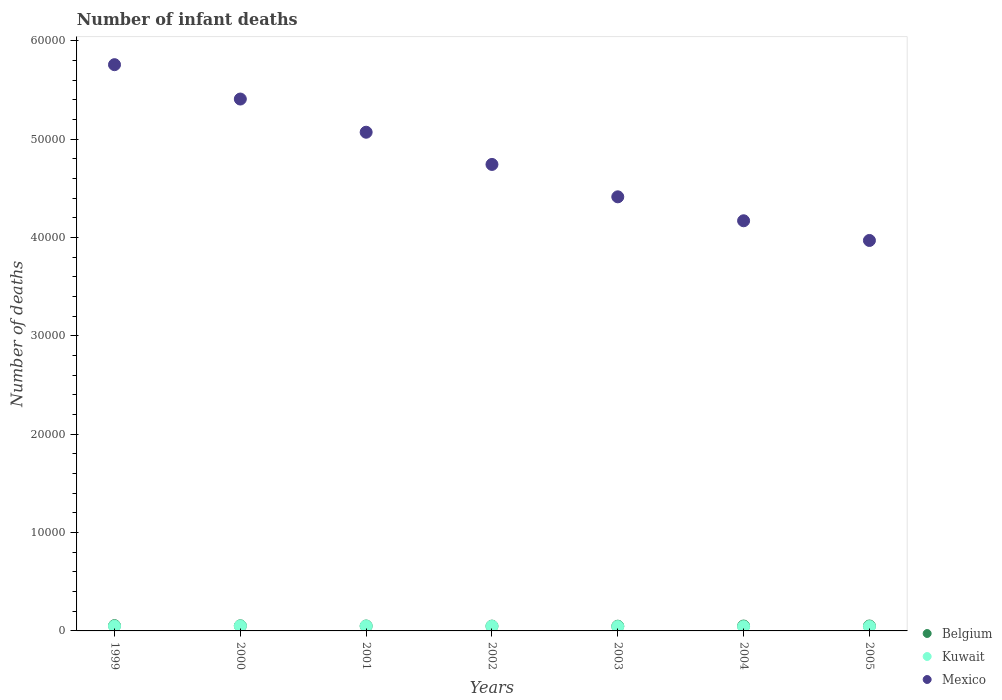How many different coloured dotlines are there?
Ensure brevity in your answer.  3. Is the number of dotlines equal to the number of legend labels?
Ensure brevity in your answer.  Yes. What is the number of infant deaths in Belgium in 2004?
Provide a short and direct response. 497. Across all years, what is the maximum number of infant deaths in Belgium?
Give a very brief answer. 536. Across all years, what is the minimum number of infant deaths in Belgium?
Make the answer very short. 481. In which year was the number of infant deaths in Kuwait maximum?
Offer a terse response. 2000. What is the total number of infant deaths in Mexico in the graph?
Your answer should be compact. 3.35e+05. What is the difference between the number of infant deaths in Mexico in 2000 and that in 2005?
Your answer should be very brief. 1.44e+04. What is the difference between the number of infant deaths in Kuwait in 2002 and the number of infant deaths in Mexico in 1999?
Give a very brief answer. -5.71e+04. What is the average number of infant deaths in Kuwait per year?
Offer a very short reply. 466.86. In the year 2005, what is the difference between the number of infant deaths in Mexico and number of infant deaths in Belgium?
Make the answer very short. 3.92e+04. In how many years, is the number of infant deaths in Belgium greater than 6000?
Provide a succinct answer. 0. What is the ratio of the number of infant deaths in Kuwait in 2000 to that in 2002?
Provide a short and direct response. 1.07. What is the difference between the highest and the second highest number of infant deaths in Belgium?
Your answer should be very brief. 16. What is the difference between the highest and the lowest number of infant deaths in Mexico?
Keep it short and to the point. 1.79e+04. Is the sum of the number of infant deaths in Kuwait in 1999 and 2000 greater than the maximum number of infant deaths in Mexico across all years?
Your answer should be compact. No. Does the number of infant deaths in Mexico monotonically increase over the years?
Provide a short and direct response. No. How many dotlines are there?
Keep it short and to the point. 3. Are the values on the major ticks of Y-axis written in scientific E-notation?
Your answer should be very brief. No. Does the graph contain any zero values?
Provide a short and direct response. No. Where does the legend appear in the graph?
Give a very brief answer. Bottom right. How many legend labels are there?
Provide a short and direct response. 3. What is the title of the graph?
Your answer should be compact. Number of infant deaths. Does "San Marino" appear as one of the legend labels in the graph?
Ensure brevity in your answer.  No. What is the label or title of the Y-axis?
Make the answer very short. Number of deaths. What is the Number of deaths of Belgium in 1999?
Provide a short and direct response. 536. What is the Number of deaths of Kuwait in 1999?
Give a very brief answer. 485. What is the Number of deaths of Mexico in 1999?
Your answer should be very brief. 5.76e+04. What is the Number of deaths of Belgium in 2000?
Your answer should be very brief. 520. What is the Number of deaths in Kuwait in 2000?
Give a very brief answer. 501. What is the Number of deaths in Mexico in 2000?
Your response must be concise. 5.41e+04. What is the Number of deaths in Belgium in 2001?
Provide a succinct answer. 501. What is the Number of deaths in Kuwait in 2001?
Give a very brief answer. 491. What is the Number of deaths in Mexico in 2001?
Keep it short and to the point. 5.07e+04. What is the Number of deaths of Belgium in 2002?
Your response must be concise. 489. What is the Number of deaths in Kuwait in 2002?
Your answer should be very brief. 470. What is the Number of deaths in Mexico in 2002?
Your answer should be compact. 4.74e+04. What is the Number of deaths of Belgium in 2003?
Make the answer very short. 481. What is the Number of deaths of Kuwait in 2003?
Ensure brevity in your answer.  442. What is the Number of deaths in Mexico in 2003?
Provide a short and direct response. 4.41e+04. What is the Number of deaths of Belgium in 2004?
Your response must be concise. 497. What is the Number of deaths of Kuwait in 2004?
Give a very brief answer. 433. What is the Number of deaths of Mexico in 2004?
Your response must be concise. 4.17e+04. What is the Number of deaths in Kuwait in 2005?
Provide a succinct answer. 446. What is the Number of deaths of Mexico in 2005?
Keep it short and to the point. 3.97e+04. Across all years, what is the maximum Number of deaths of Belgium?
Your answer should be very brief. 536. Across all years, what is the maximum Number of deaths of Kuwait?
Offer a terse response. 501. Across all years, what is the maximum Number of deaths in Mexico?
Give a very brief answer. 5.76e+04. Across all years, what is the minimum Number of deaths of Belgium?
Your answer should be very brief. 481. Across all years, what is the minimum Number of deaths in Kuwait?
Ensure brevity in your answer.  433. Across all years, what is the minimum Number of deaths in Mexico?
Your answer should be compact. 3.97e+04. What is the total Number of deaths of Belgium in the graph?
Make the answer very short. 3524. What is the total Number of deaths in Kuwait in the graph?
Keep it short and to the point. 3268. What is the total Number of deaths in Mexico in the graph?
Provide a short and direct response. 3.35e+05. What is the difference between the Number of deaths in Belgium in 1999 and that in 2000?
Your response must be concise. 16. What is the difference between the Number of deaths of Mexico in 1999 and that in 2000?
Give a very brief answer. 3494. What is the difference between the Number of deaths in Kuwait in 1999 and that in 2001?
Your response must be concise. -6. What is the difference between the Number of deaths of Mexico in 1999 and that in 2001?
Provide a short and direct response. 6869. What is the difference between the Number of deaths of Mexico in 1999 and that in 2002?
Your answer should be very brief. 1.01e+04. What is the difference between the Number of deaths of Belgium in 1999 and that in 2003?
Provide a succinct answer. 55. What is the difference between the Number of deaths in Mexico in 1999 and that in 2003?
Keep it short and to the point. 1.34e+04. What is the difference between the Number of deaths of Mexico in 1999 and that in 2004?
Offer a very short reply. 1.59e+04. What is the difference between the Number of deaths in Belgium in 1999 and that in 2005?
Give a very brief answer. 36. What is the difference between the Number of deaths in Mexico in 1999 and that in 2005?
Your answer should be very brief. 1.79e+04. What is the difference between the Number of deaths of Mexico in 2000 and that in 2001?
Make the answer very short. 3375. What is the difference between the Number of deaths in Kuwait in 2000 and that in 2002?
Ensure brevity in your answer.  31. What is the difference between the Number of deaths in Mexico in 2000 and that in 2002?
Provide a short and direct response. 6650. What is the difference between the Number of deaths in Belgium in 2000 and that in 2003?
Make the answer very short. 39. What is the difference between the Number of deaths of Kuwait in 2000 and that in 2003?
Provide a succinct answer. 59. What is the difference between the Number of deaths in Mexico in 2000 and that in 2003?
Offer a terse response. 9943. What is the difference between the Number of deaths of Mexico in 2000 and that in 2004?
Offer a terse response. 1.24e+04. What is the difference between the Number of deaths of Belgium in 2000 and that in 2005?
Give a very brief answer. 20. What is the difference between the Number of deaths of Kuwait in 2000 and that in 2005?
Your answer should be very brief. 55. What is the difference between the Number of deaths of Mexico in 2000 and that in 2005?
Make the answer very short. 1.44e+04. What is the difference between the Number of deaths of Kuwait in 2001 and that in 2002?
Give a very brief answer. 21. What is the difference between the Number of deaths of Mexico in 2001 and that in 2002?
Provide a short and direct response. 3275. What is the difference between the Number of deaths in Belgium in 2001 and that in 2003?
Offer a very short reply. 20. What is the difference between the Number of deaths in Mexico in 2001 and that in 2003?
Ensure brevity in your answer.  6568. What is the difference between the Number of deaths in Belgium in 2001 and that in 2004?
Give a very brief answer. 4. What is the difference between the Number of deaths in Kuwait in 2001 and that in 2004?
Give a very brief answer. 58. What is the difference between the Number of deaths of Mexico in 2001 and that in 2004?
Your answer should be very brief. 9003. What is the difference between the Number of deaths of Kuwait in 2001 and that in 2005?
Provide a succinct answer. 45. What is the difference between the Number of deaths of Mexico in 2001 and that in 2005?
Ensure brevity in your answer.  1.10e+04. What is the difference between the Number of deaths in Belgium in 2002 and that in 2003?
Provide a short and direct response. 8. What is the difference between the Number of deaths of Kuwait in 2002 and that in 2003?
Offer a terse response. 28. What is the difference between the Number of deaths of Mexico in 2002 and that in 2003?
Your answer should be compact. 3293. What is the difference between the Number of deaths in Mexico in 2002 and that in 2004?
Offer a terse response. 5728. What is the difference between the Number of deaths in Belgium in 2002 and that in 2005?
Offer a very short reply. -11. What is the difference between the Number of deaths of Mexico in 2002 and that in 2005?
Provide a succinct answer. 7730. What is the difference between the Number of deaths of Kuwait in 2003 and that in 2004?
Ensure brevity in your answer.  9. What is the difference between the Number of deaths in Mexico in 2003 and that in 2004?
Give a very brief answer. 2435. What is the difference between the Number of deaths in Mexico in 2003 and that in 2005?
Provide a succinct answer. 4437. What is the difference between the Number of deaths in Mexico in 2004 and that in 2005?
Your answer should be compact. 2002. What is the difference between the Number of deaths in Belgium in 1999 and the Number of deaths in Kuwait in 2000?
Provide a short and direct response. 35. What is the difference between the Number of deaths in Belgium in 1999 and the Number of deaths in Mexico in 2000?
Make the answer very short. -5.35e+04. What is the difference between the Number of deaths in Kuwait in 1999 and the Number of deaths in Mexico in 2000?
Offer a terse response. -5.36e+04. What is the difference between the Number of deaths in Belgium in 1999 and the Number of deaths in Kuwait in 2001?
Give a very brief answer. 45. What is the difference between the Number of deaths in Belgium in 1999 and the Number of deaths in Mexico in 2001?
Provide a short and direct response. -5.02e+04. What is the difference between the Number of deaths of Kuwait in 1999 and the Number of deaths of Mexico in 2001?
Offer a terse response. -5.02e+04. What is the difference between the Number of deaths in Belgium in 1999 and the Number of deaths in Kuwait in 2002?
Provide a succinct answer. 66. What is the difference between the Number of deaths in Belgium in 1999 and the Number of deaths in Mexico in 2002?
Ensure brevity in your answer.  -4.69e+04. What is the difference between the Number of deaths in Kuwait in 1999 and the Number of deaths in Mexico in 2002?
Provide a short and direct response. -4.69e+04. What is the difference between the Number of deaths of Belgium in 1999 and the Number of deaths of Kuwait in 2003?
Offer a terse response. 94. What is the difference between the Number of deaths of Belgium in 1999 and the Number of deaths of Mexico in 2003?
Your answer should be very brief. -4.36e+04. What is the difference between the Number of deaths of Kuwait in 1999 and the Number of deaths of Mexico in 2003?
Keep it short and to the point. -4.37e+04. What is the difference between the Number of deaths in Belgium in 1999 and the Number of deaths in Kuwait in 2004?
Make the answer very short. 103. What is the difference between the Number of deaths in Belgium in 1999 and the Number of deaths in Mexico in 2004?
Your answer should be compact. -4.12e+04. What is the difference between the Number of deaths of Kuwait in 1999 and the Number of deaths of Mexico in 2004?
Provide a succinct answer. -4.12e+04. What is the difference between the Number of deaths of Belgium in 1999 and the Number of deaths of Kuwait in 2005?
Provide a short and direct response. 90. What is the difference between the Number of deaths of Belgium in 1999 and the Number of deaths of Mexico in 2005?
Ensure brevity in your answer.  -3.92e+04. What is the difference between the Number of deaths in Kuwait in 1999 and the Number of deaths in Mexico in 2005?
Your answer should be compact. -3.92e+04. What is the difference between the Number of deaths in Belgium in 2000 and the Number of deaths in Kuwait in 2001?
Keep it short and to the point. 29. What is the difference between the Number of deaths of Belgium in 2000 and the Number of deaths of Mexico in 2001?
Provide a short and direct response. -5.02e+04. What is the difference between the Number of deaths of Kuwait in 2000 and the Number of deaths of Mexico in 2001?
Make the answer very short. -5.02e+04. What is the difference between the Number of deaths in Belgium in 2000 and the Number of deaths in Mexico in 2002?
Keep it short and to the point. -4.69e+04. What is the difference between the Number of deaths in Kuwait in 2000 and the Number of deaths in Mexico in 2002?
Keep it short and to the point. -4.69e+04. What is the difference between the Number of deaths of Belgium in 2000 and the Number of deaths of Mexico in 2003?
Provide a short and direct response. -4.36e+04. What is the difference between the Number of deaths in Kuwait in 2000 and the Number of deaths in Mexico in 2003?
Give a very brief answer. -4.36e+04. What is the difference between the Number of deaths of Belgium in 2000 and the Number of deaths of Kuwait in 2004?
Provide a short and direct response. 87. What is the difference between the Number of deaths of Belgium in 2000 and the Number of deaths of Mexico in 2004?
Your answer should be compact. -4.12e+04. What is the difference between the Number of deaths of Kuwait in 2000 and the Number of deaths of Mexico in 2004?
Offer a very short reply. -4.12e+04. What is the difference between the Number of deaths of Belgium in 2000 and the Number of deaths of Kuwait in 2005?
Provide a short and direct response. 74. What is the difference between the Number of deaths of Belgium in 2000 and the Number of deaths of Mexico in 2005?
Ensure brevity in your answer.  -3.92e+04. What is the difference between the Number of deaths of Kuwait in 2000 and the Number of deaths of Mexico in 2005?
Provide a short and direct response. -3.92e+04. What is the difference between the Number of deaths of Belgium in 2001 and the Number of deaths of Kuwait in 2002?
Make the answer very short. 31. What is the difference between the Number of deaths of Belgium in 2001 and the Number of deaths of Mexico in 2002?
Keep it short and to the point. -4.69e+04. What is the difference between the Number of deaths of Kuwait in 2001 and the Number of deaths of Mexico in 2002?
Make the answer very short. -4.69e+04. What is the difference between the Number of deaths in Belgium in 2001 and the Number of deaths in Mexico in 2003?
Keep it short and to the point. -4.36e+04. What is the difference between the Number of deaths in Kuwait in 2001 and the Number of deaths in Mexico in 2003?
Offer a very short reply. -4.36e+04. What is the difference between the Number of deaths of Belgium in 2001 and the Number of deaths of Kuwait in 2004?
Offer a very short reply. 68. What is the difference between the Number of deaths in Belgium in 2001 and the Number of deaths in Mexico in 2004?
Keep it short and to the point. -4.12e+04. What is the difference between the Number of deaths in Kuwait in 2001 and the Number of deaths in Mexico in 2004?
Provide a succinct answer. -4.12e+04. What is the difference between the Number of deaths in Belgium in 2001 and the Number of deaths in Mexico in 2005?
Offer a terse response. -3.92e+04. What is the difference between the Number of deaths of Kuwait in 2001 and the Number of deaths of Mexico in 2005?
Your response must be concise. -3.92e+04. What is the difference between the Number of deaths of Belgium in 2002 and the Number of deaths of Kuwait in 2003?
Ensure brevity in your answer.  47. What is the difference between the Number of deaths of Belgium in 2002 and the Number of deaths of Mexico in 2003?
Your response must be concise. -4.37e+04. What is the difference between the Number of deaths of Kuwait in 2002 and the Number of deaths of Mexico in 2003?
Ensure brevity in your answer.  -4.37e+04. What is the difference between the Number of deaths in Belgium in 2002 and the Number of deaths in Kuwait in 2004?
Your response must be concise. 56. What is the difference between the Number of deaths in Belgium in 2002 and the Number of deaths in Mexico in 2004?
Your answer should be compact. -4.12e+04. What is the difference between the Number of deaths of Kuwait in 2002 and the Number of deaths of Mexico in 2004?
Offer a very short reply. -4.12e+04. What is the difference between the Number of deaths in Belgium in 2002 and the Number of deaths in Mexico in 2005?
Your answer should be compact. -3.92e+04. What is the difference between the Number of deaths of Kuwait in 2002 and the Number of deaths of Mexico in 2005?
Your answer should be very brief. -3.92e+04. What is the difference between the Number of deaths in Belgium in 2003 and the Number of deaths in Kuwait in 2004?
Give a very brief answer. 48. What is the difference between the Number of deaths of Belgium in 2003 and the Number of deaths of Mexico in 2004?
Give a very brief answer. -4.12e+04. What is the difference between the Number of deaths of Kuwait in 2003 and the Number of deaths of Mexico in 2004?
Make the answer very short. -4.13e+04. What is the difference between the Number of deaths of Belgium in 2003 and the Number of deaths of Kuwait in 2005?
Provide a succinct answer. 35. What is the difference between the Number of deaths of Belgium in 2003 and the Number of deaths of Mexico in 2005?
Offer a terse response. -3.92e+04. What is the difference between the Number of deaths of Kuwait in 2003 and the Number of deaths of Mexico in 2005?
Provide a short and direct response. -3.93e+04. What is the difference between the Number of deaths in Belgium in 2004 and the Number of deaths in Mexico in 2005?
Your answer should be compact. -3.92e+04. What is the difference between the Number of deaths of Kuwait in 2004 and the Number of deaths of Mexico in 2005?
Ensure brevity in your answer.  -3.93e+04. What is the average Number of deaths of Belgium per year?
Provide a succinct answer. 503.43. What is the average Number of deaths in Kuwait per year?
Give a very brief answer. 466.86. What is the average Number of deaths in Mexico per year?
Your answer should be very brief. 4.79e+04. In the year 1999, what is the difference between the Number of deaths of Belgium and Number of deaths of Kuwait?
Give a very brief answer. 51. In the year 1999, what is the difference between the Number of deaths of Belgium and Number of deaths of Mexico?
Offer a terse response. -5.70e+04. In the year 1999, what is the difference between the Number of deaths of Kuwait and Number of deaths of Mexico?
Ensure brevity in your answer.  -5.71e+04. In the year 2000, what is the difference between the Number of deaths in Belgium and Number of deaths in Mexico?
Offer a terse response. -5.36e+04. In the year 2000, what is the difference between the Number of deaths in Kuwait and Number of deaths in Mexico?
Offer a terse response. -5.36e+04. In the year 2001, what is the difference between the Number of deaths of Belgium and Number of deaths of Kuwait?
Make the answer very short. 10. In the year 2001, what is the difference between the Number of deaths in Belgium and Number of deaths in Mexico?
Provide a short and direct response. -5.02e+04. In the year 2001, what is the difference between the Number of deaths of Kuwait and Number of deaths of Mexico?
Your response must be concise. -5.02e+04. In the year 2002, what is the difference between the Number of deaths of Belgium and Number of deaths of Mexico?
Ensure brevity in your answer.  -4.69e+04. In the year 2002, what is the difference between the Number of deaths in Kuwait and Number of deaths in Mexico?
Ensure brevity in your answer.  -4.70e+04. In the year 2003, what is the difference between the Number of deaths in Belgium and Number of deaths in Mexico?
Your answer should be compact. -4.37e+04. In the year 2003, what is the difference between the Number of deaths in Kuwait and Number of deaths in Mexico?
Provide a succinct answer. -4.37e+04. In the year 2004, what is the difference between the Number of deaths in Belgium and Number of deaths in Kuwait?
Your response must be concise. 64. In the year 2004, what is the difference between the Number of deaths of Belgium and Number of deaths of Mexico?
Ensure brevity in your answer.  -4.12e+04. In the year 2004, what is the difference between the Number of deaths of Kuwait and Number of deaths of Mexico?
Ensure brevity in your answer.  -4.13e+04. In the year 2005, what is the difference between the Number of deaths of Belgium and Number of deaths of Kuwait?
Offer a very short reply. 54. In the year 2005, what is the difference between the Number of deaths of Belgium and Number of deaths of Mexico?
Provide a short and direct response. -3.92e+04. In the year 2005, what is the difference between the Number of deaths in Kuwait and Number of deaths in Mexico?
Your response must be concise. -3.93e+04. What is the ratio of the Number of deaths in Belgium in 1999 to that in 2000?
Give a very brief answer. 1.03. What is the ratio of the Number of deaths of Kuwait in 1999 to that in 2000?
Provide a succinct answer. 0.97. What is the ratio of the Number of deaths of Mexico in 1999 to that in 2000?
Offer a terse response. 1.06. What is the ratio of the Number of deaths of Belgium in 1999 to that in 2001?
Your response must be concise. 1.07. What is the ratio of the Number of deaths of Kuwait in 1999 to that in 2001?
Your response must be concise. 0.99. What is the ratio of the Number of deaths of Mexico in 1999 to that in 2001?
Provide a short and direct response. 1.14. What is the ratio of the Number of deaths in Belgium in 1999 to that in 2002?
Make the answer very short. 1.1. What is the ratio of the Number of deaths of Kuwait in 1999 to that in 2002?
Offer a terse response. 1.03. What is the ratio of the Number of deaths of Mexico in 1999 to that in 2002?
Keep it short and to the point. 1.21. What is the ratio of the Number of deaths of Belgium in 1999 to that in 2003?
Give a very brief answer. 1.11. What is the ratio of the Number of deaths in Kuwait in 1999 to that in 2003?
Your answer should be compact. 1.1. What is the ratio of the Number of deaths in Mexico in 1999 to that in 2003?
Your response must be concise. 1.3. What is the ratio of the Number of deaths in Belgium in 1999 to that in 2004?
Give a very brief answer. 1.08. What is the ratio of the Number of deaths in Kuwait in 1999 to that in 2004?
Offer a very short reply. 1.12. What is the ratio of the Number of deaths in Mexico in 1999 to that in 2004?
Your answer should be compact. 1.38. What is the ratio of the Number of deaths of Belgium in 1999 to that in 2005?
Provide a short and direct response. 1.07. What is the ratio of the Number of deaths in Kuwait in 1999 to that in 2005?
Your answer should be compact. 1.09. What is the ratio of the Number of deaths of Mexico in 1999 to that in 2005?
Give a very brief answer. 1.45. What is the ratio of the Number of deaths in Belgium in 2000 to that in 2001?
Give a very brief answer. 1.04. What is the ratio of the Number of deaths in Kuwait in 2000 to that in 2001?
Provide a short and direct response. 1.02. What is the ratio of the Number of deaths in Mexico in 2000 to that in 2001?
Keep it short and to the point. 1.07. What is the ratio of the Number of deaths of Belgium in 2000 to that in 2002?
Your answer should be very brief. 1.06. What is the ratio of the Number of deaths of Kuwait in 2000 to that in 2002?
Provide a short and direct response. 1.07. What is the ratio of the Number of deaths of Mexico in 2000 to that in 2002?
Offer a very short reply. 1.14. What is the ratio of the Number of deaths of Belgium in 2000 to that in 2003?
Keep it short and to the point. 1.08. What is the ratio of the Number of deaths in Kuwait in 2000 to that in 2003?
Make the answer very short. 1.13. What is the ratio of the Number of deaths in Mexico in 2000 to that in 2003?
Provide a short and direct response. 1.23. What is the ratio of the Number of deaths in Belgium in 2000 to that in 2004?
Offer a terse response. 1.05. What is the ratio of the Number of deaths of Kuwait in 2000 to that in 2004?
Offer a terse response. 1.16. What is the ratio of the Number of deaths in Mexico in 2000 to that in 2004?
Offer a terse response. 1.3. What is the ratio of the Number of deaths of Belgium in 2000 to that in 2005?
Your response must be concise. 1.04. What is the ratio of the Number of deaths in Kuwait in 2000 to that in 2005?
Your answer should be very brief. 1.12. What is the ratio of the Number of deaths of Mexico in 2000 to that in 2005?
Provide a short and direct response. 1.36. What is the ratio of the Number of deaths of Belgium in 2001 to that in 2002?
Your answer should be compact. 1.02. What is the ratio of the Number of deaths of Kuwait in 2001 to that in 2002?
Ensure brevity in your answer.  1.04. What is the ratio of the Number of deaths of Mexico in 2001 to that in 2002?
Keep it short and to the point. 1.07. What is the ratio of the Number of deaths of Belgium in 2001 to that in 2003?
Your answer should be very brief. 1.04. What is the ratio of the Number of deaths in Kuwait in 2001 to that in 2003?
Make the answer very short. 1.11. What is the ratio of the Number of deaths in Mexico in 2001 to that in 2003?
Ensure brevity in your answer.  1.15. What is the ratio of the Number of deaths in Kuwait in 2001 to that in 2004?
Make the answer very short. 1.13. What is the ratio of the Number of deaths in Mexico in 2001 to that in 2004?
Your response must be concise. 1.22. What is the ratio of the Number of deaths in Belgium in 2001 to that in 2005?
Make the answer very short. 1. What is the ratio of the Number of deaths of Kuwait in 2001 to that in 2005?
Provide a short and direct response. 1.1. What is the ratio of the Number of deaths in Mexico in 2001 to that in 2005?
Offer a very short reply. 1.28. What is the ratio of the Number of deaths of Belgium in 2002 to that in 2003?
Your answer should be compact. 1.02. What is the ratio of the Number of deaths of Kuwait in 2002 to that in 2003?
Offer a terse response. 1.06. What is the ratio of the Number of deaths in Mexico in 2002 to that in 2003?
Keep it short and to the point. 1.07. What is the ratio of the Number of deaths in Belgium in 2002 to that in 2004?
Provide a succinct answer. 0.98. What is the ratio of the Number of deaths of Kuwait in 2002 to that in 2004?
Ensure brevity in your answer.  1.09. What is the ratio of the Number of deaths in Mexico in 2002 to that in 2004?
Ensure brevity in your answer.  1.14. What is the ratio of the Number of deaths of Belgium in 2002 to that in 2005?
Offer a very short reply. 0.98. What is the ratio of the Number of deaths of Kuwait in 2002 to that in 2005?
Your response must be concise. 1.05. What is the ratio of the Number of deaths in Mexico in 2002 to that in 2005?
Give a very brief answer. 1.19. What is the ratio of the Number of deaths of Belgium in 2003 to that in 2004?
Keep it short and to the point. 0.97. What is the ratio of the Number of deaths in Kuwait in 2003 to that in 2004?
Keep it short and to the point. 1.02. What is the ratio of the Number of deaths in Mexico in 2003 to that in 2004?
Give a very brief answer. 1.06. What is the ratio of the Number of deaths of Mexico in 2003 to that in 2005?
Give a very brief answer. 1.11. What is the ratio of the Number of deaths in Belgium in 2004 to that in 2005?
Provide a succinct answer. 0.99. What is the ratio of the Number of deaths of Kuwait in 2004 to that in 2005?
Ensure brevity in your answer.  0.97. What is the ratio of the Number of deaths in Mexico in 2004 to that in 2005?
Give a very brief answer. 1.05. What is the difference between the highest and the second highest Number of deaths of Belgium?
Your answer should be compact. 16. What is the difference between the highest and the second highest Number of deaths in Mexico?
Give a very brief answer. 3494. What is the difference between the highest and the lowest Number of deaths of Kuwait?
Your response must be concise. 68. What is the difference between the highest and the lowest Number of deaths of Mexico?
Offer a terse response. 1.79e+04. 